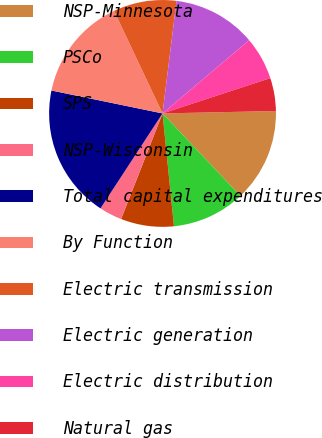Convert chart. <chart><loc_0><loc_0><loc_500><loc_500><pie_chart><fcel>NSP-Minnesota<fcel>PSCo<fcel>SPS<fcel>NSP-Wisconsin<fcel>Total capital expenditures<fcel>By Function<fcel>Electric transmission<fcel>Electric generation<fcel>Electric distribution<fcel>Natural gas<nl><fcel>13.3%<fcel>10.43%<fcel>7.56%<fcel>3.26%<fcel>19.03%<fcel>14.73%<fcel>9.0%<fcel>11.86%<fcel>6.13%<fcel>4.7%<nl></chart> 